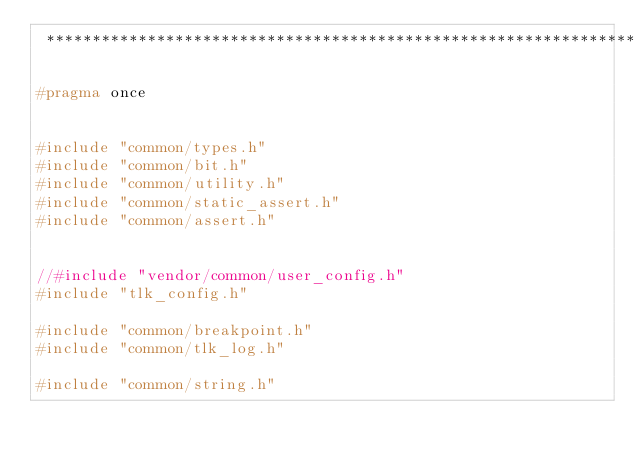Convert code to text. <code><loc_0><loc_0><loc_500><loc_500><_C_> *******************************************************************************************************/

#pragma once


#include "common/types.h"
#include "common/bit.h"
#include "common/utility.h"
#include "common/static_assert.h"
#include "common/assert.h"


//#include "vendor/common/user_config.h"
#include "tlk_config.h"

#include "common/breakpoint.h"
#include "common/tlk_log.h"

#include "common/string.h"

</code> 